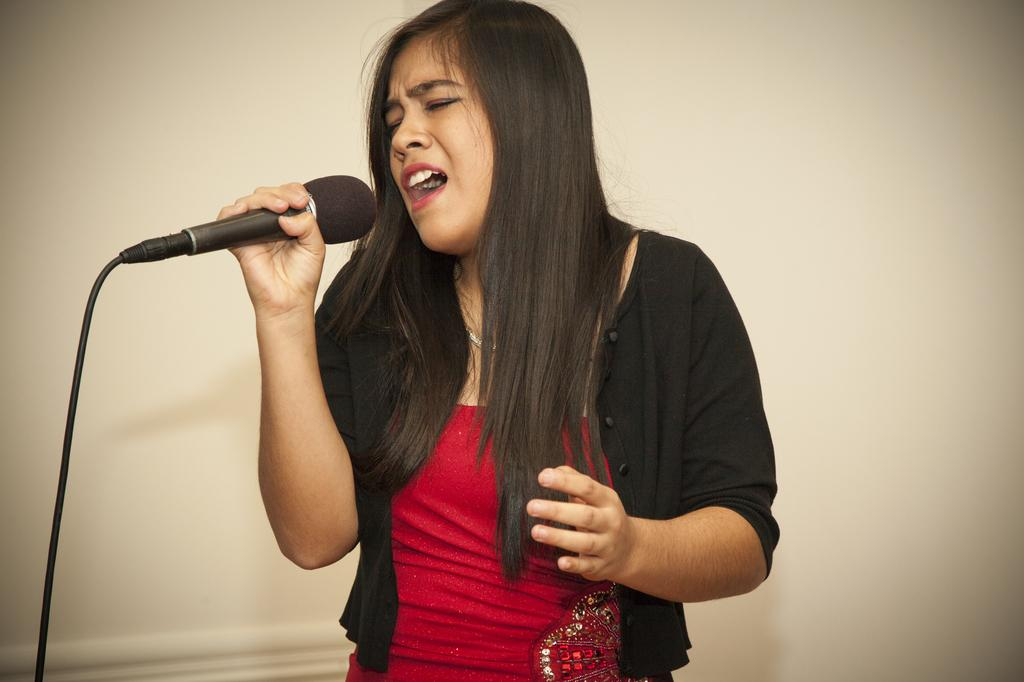Who is the main subject in the image? There is a woman in the image. What is the woman holding in the image? The woman is holding a microphone. What type of clothing is the woman wearing in the image? The woman is wearing a shrug. What day of the week is depicted on the calendar in the image? There is no calendar present in the image. What type of pleasure can be seen being experienced by the woman in the image? The image does not depict any specific pleasure being experienced by the woman. 